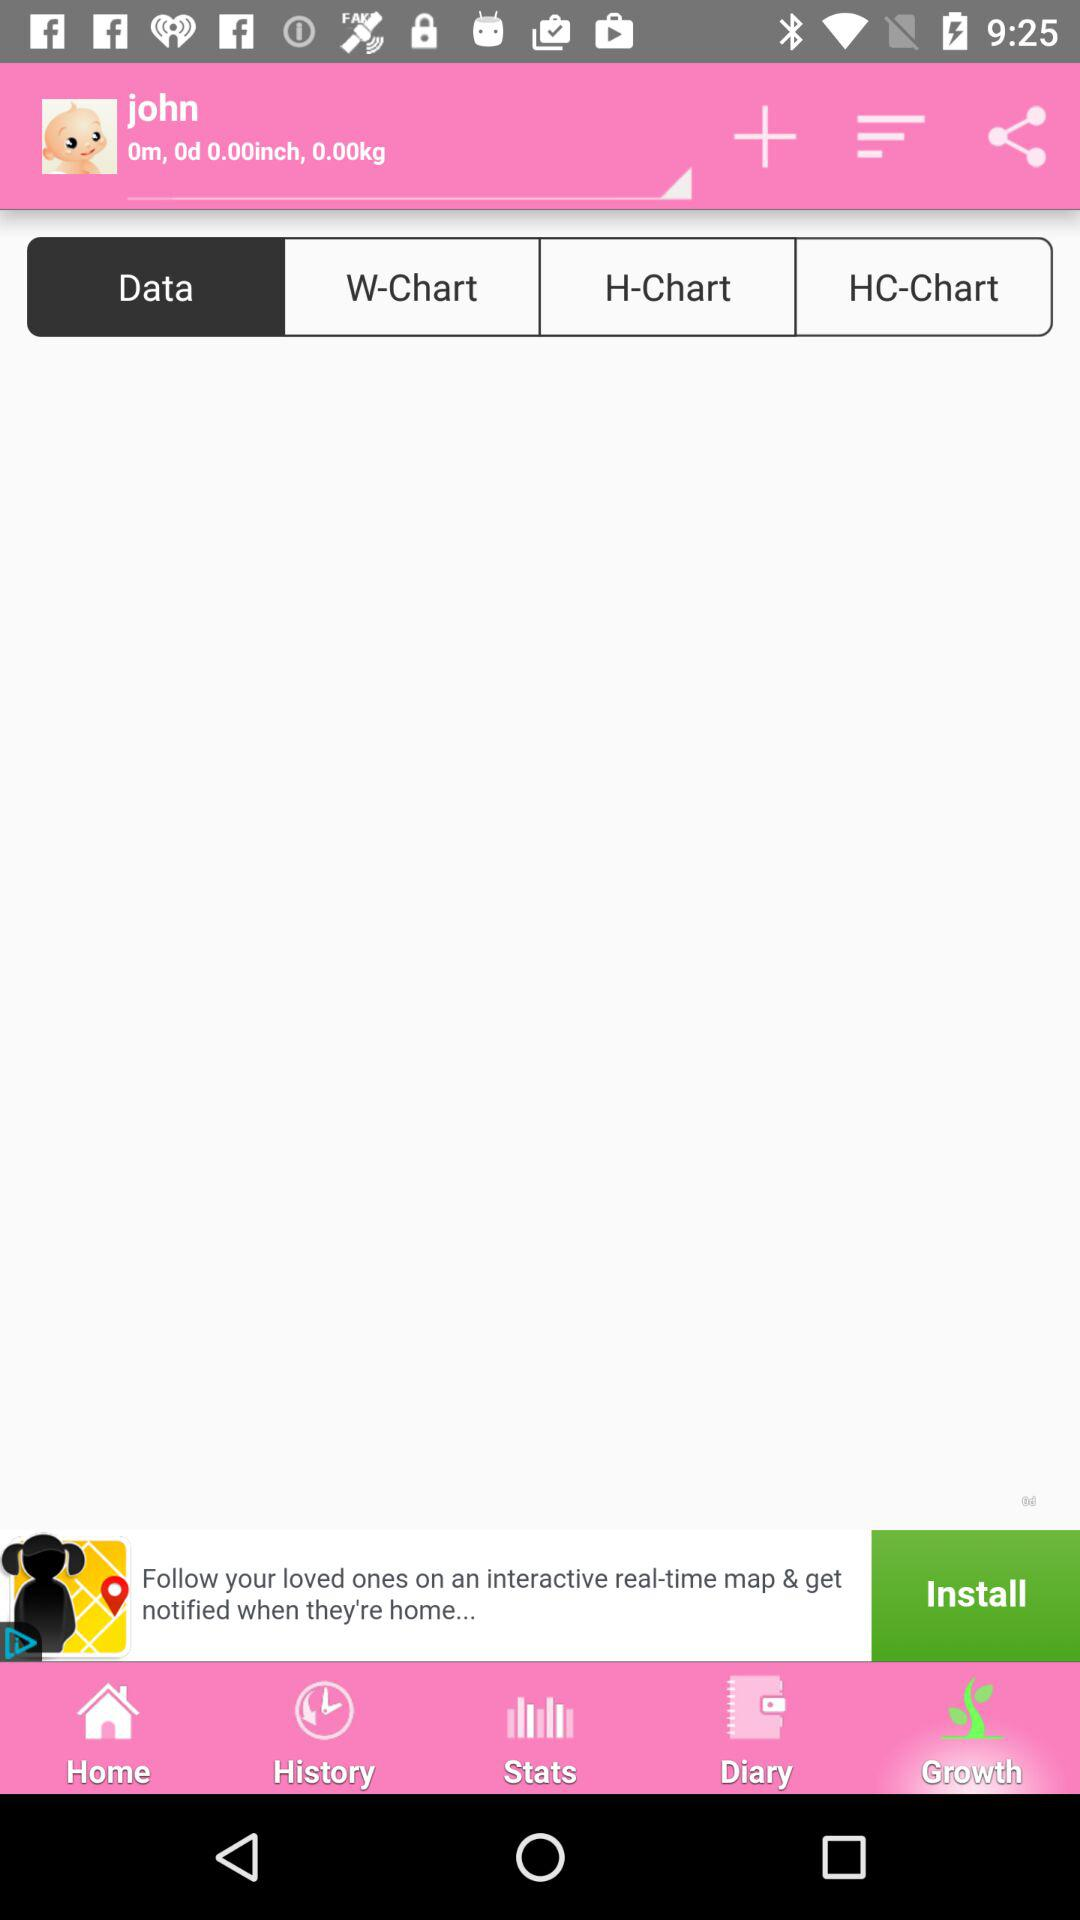Is "john" male or female?
When the provided information is insufficient, respond with <no answer>. <no answer> 